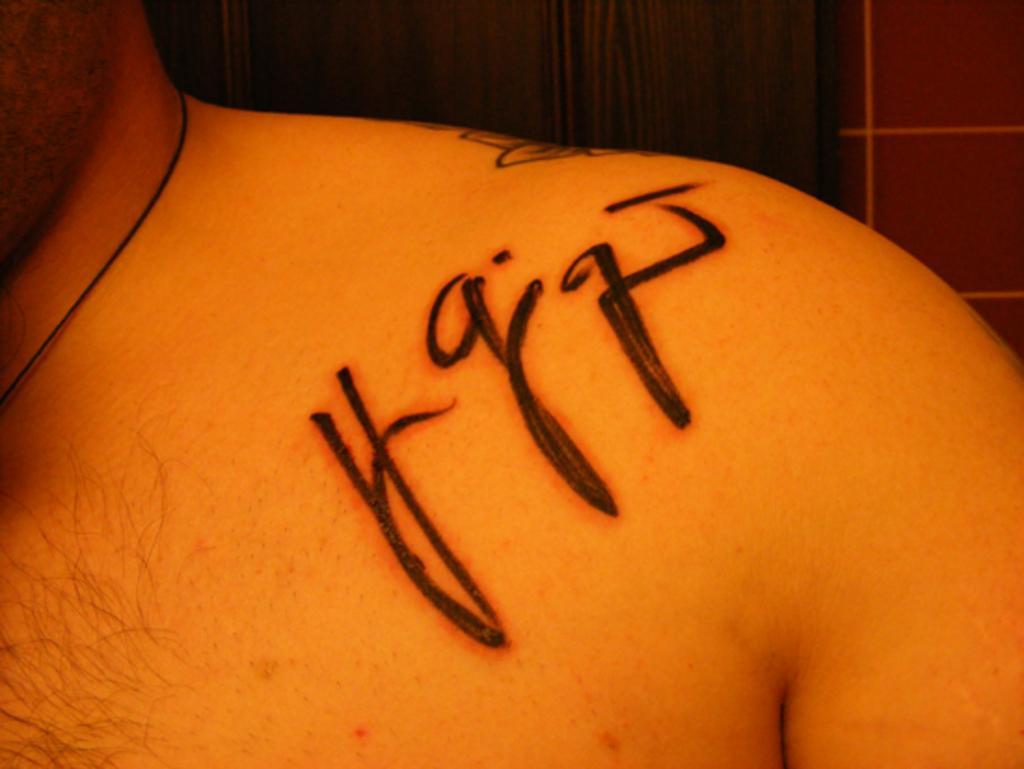Could you give a brief overview of what you see in this image? In this image I can see the tattoo on the person and I can see the brown color background. 